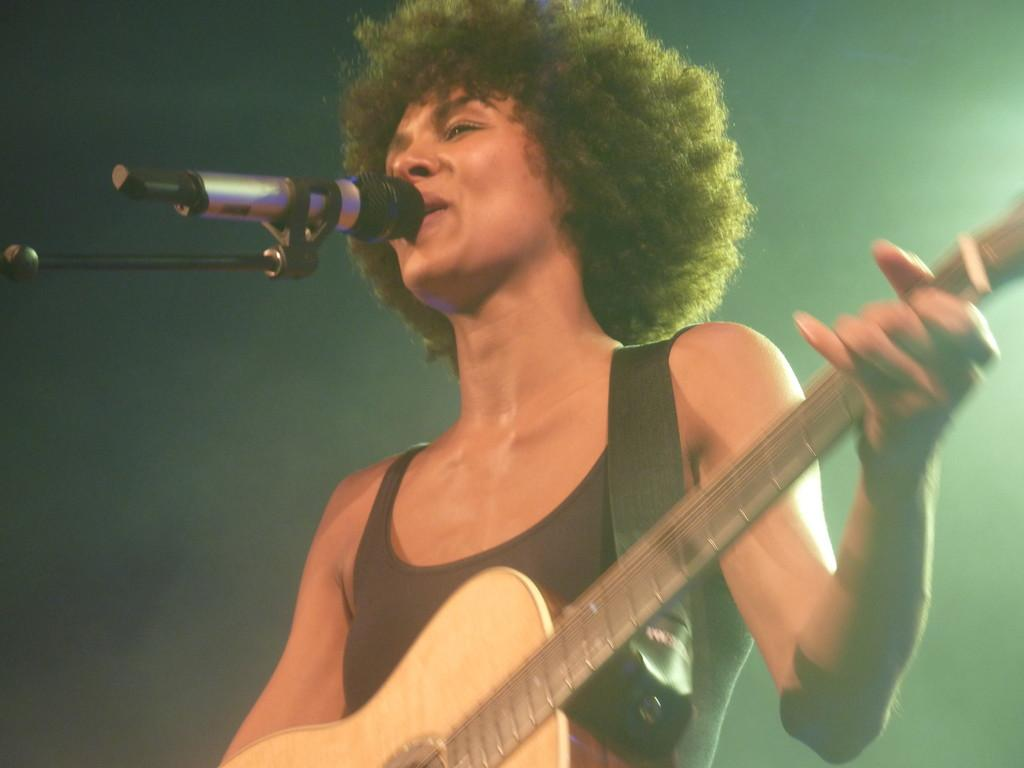Who is the main subject in the image? There is a woman in the image. What is the woman holding in the image? The woman is holding a guitar. What is the woman doing in the image? The woman is singing a song. What is in front of the woman in the image? There is a microphone with a stand in front of the woman. What is the color of the background in the image? The background of the image is in black color. What type of weather can be seen in the image? There is no weather visible in the image, as it is an indoor scene with a black background. 